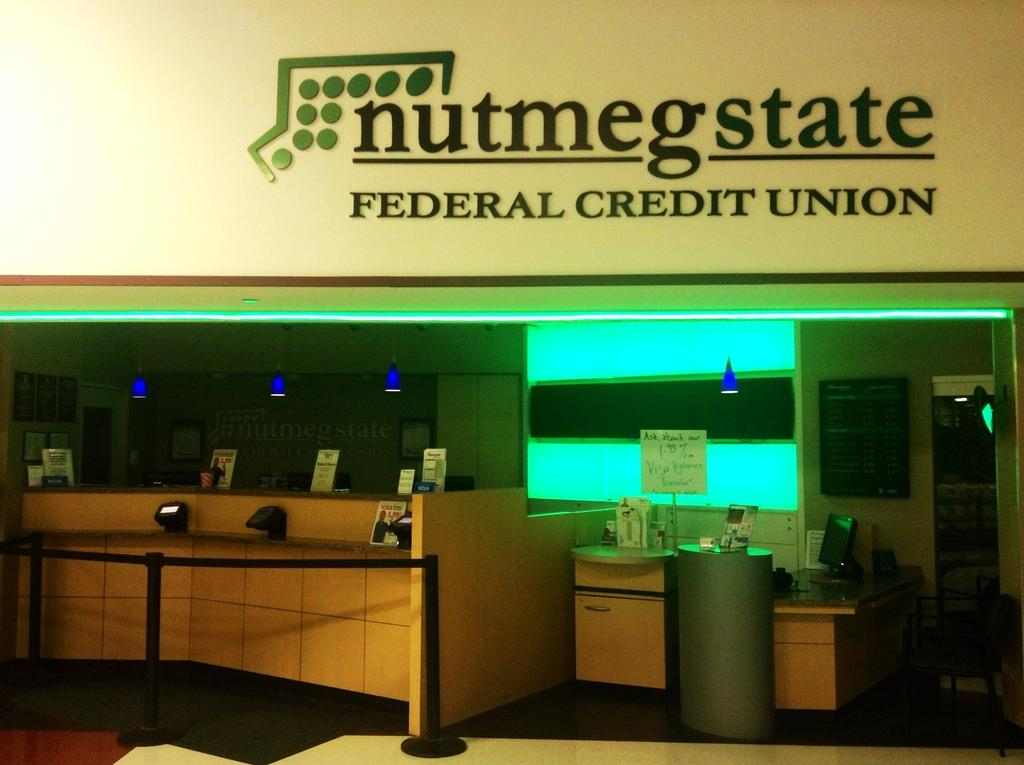<image>
Write a terse but informative summary of the picture. the word federal credit union is on the sign 